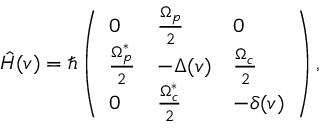<formula> <loc_0><loc_0><loc_500><loc_500>\hat { H } ( v ) = \hbar { \left } ( \begin{array} { l l l } { 0 } & { \frac { \Omega _ { p } } { 2 } } & { 0 } \\ { \frac { \Omega _ { p } ^ { * } } { 2 } } & { - \Delta ( v ) } & { \frac { \Omega _ { c } } { 2 } } \\ { 0 } & { \frac { \Omega _ { c } ^ { * } } { 2 } } & { - \delta ( v ) } \end{array} \right ) ,</formula> 